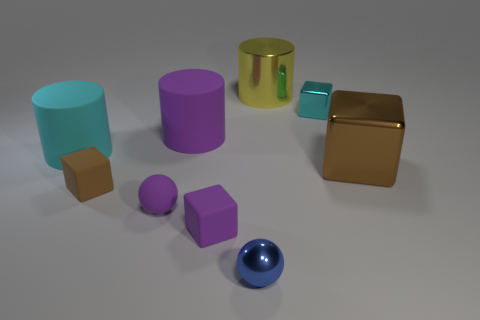How many other objects are the same material as the cyan cylinder?
Provide a succinct answer. 4. What material is the purple object that is the same size as the yellow thing?
Your answer should be compact. Rubber. Is the number of purple cylinders that are left of the large cyan object greater than the number of tiny purple matte objects in front of the tiny brown matte block?
Give a very brief answer. No. Is there a big yellow shiny object of the same shape as the big cyan rubber thing?
Provide a short and direct response. Yes. What is the shape of the yellow metal thing that is the same size as the cyan cylinder?
Give a very brief answer. Cylinder. There is a tiny metallic object behind the purple cube; what shape is it?
Ensure brevity in your answer.  Cube. Is the number of cyan rubber things that are to the right of the large purple matte object less than the number of large cyan cylinders in front of the small brown object?
Give a very brief answer. No. There is a purple cylinder; is it the same size as the shiny cube that is in front of the small cyan shiny block?
Ensure brevity in your answer.  Yes. What number of blue spheres are the same size as the cyan metal object?
Offer a terse response. 1. The large thing that is the same material as the big block is what color?
Keep it short and to the point. Yellow. 